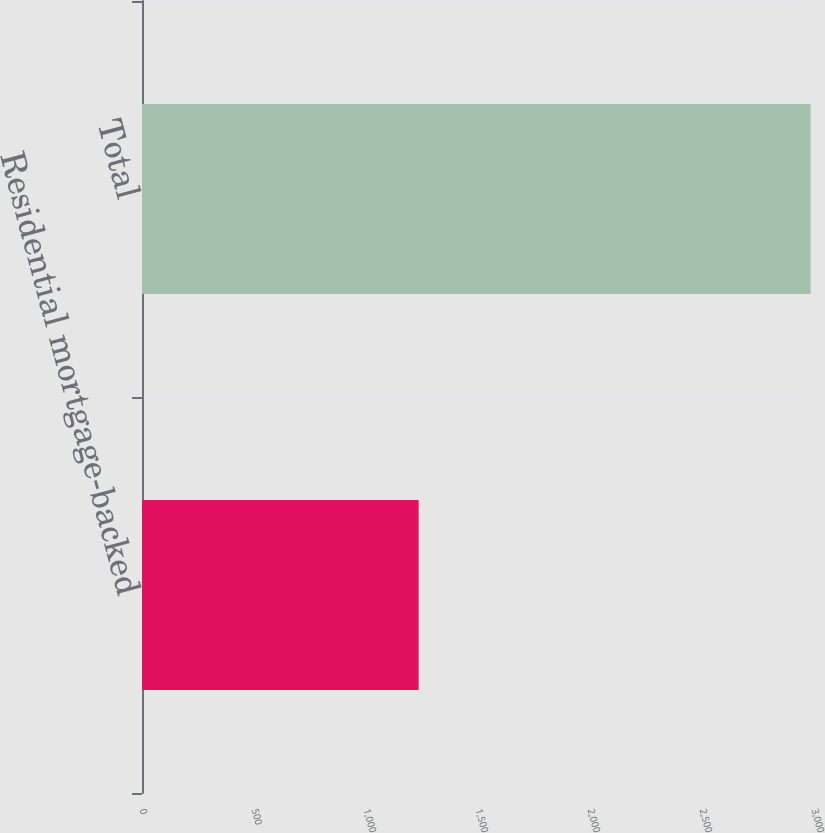<chart> <loc_0><loc_0><loc_500><loc_500><bar_chart><fcel>Residential mortgage-backed<fcel>Total<nl><fcel>1235<fcel>2985<nl></chart> 